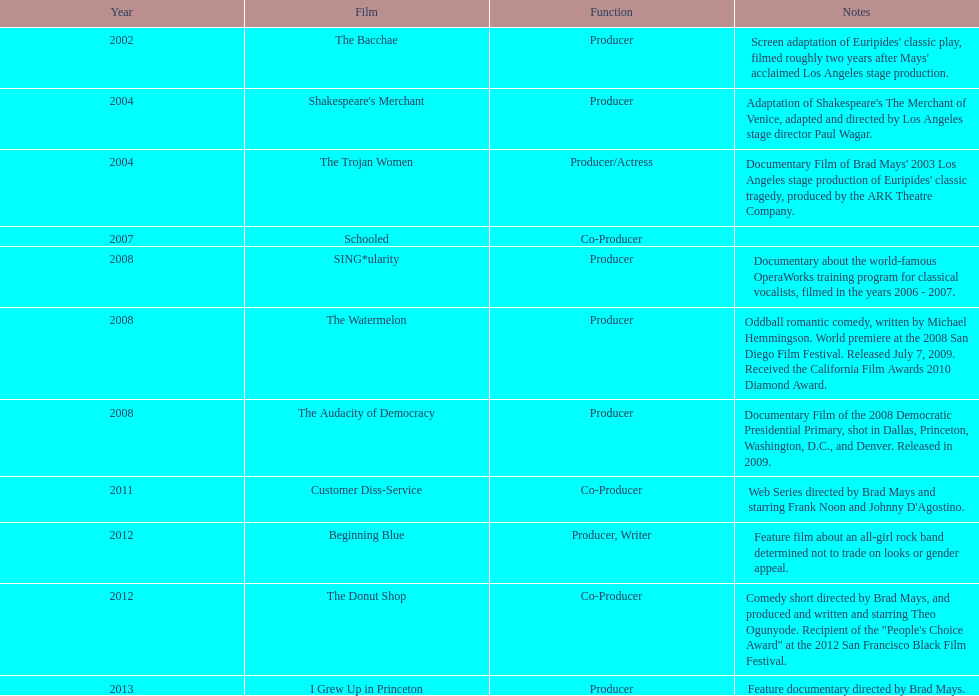Which film was before the audacity of democracy? The Watermelon. 